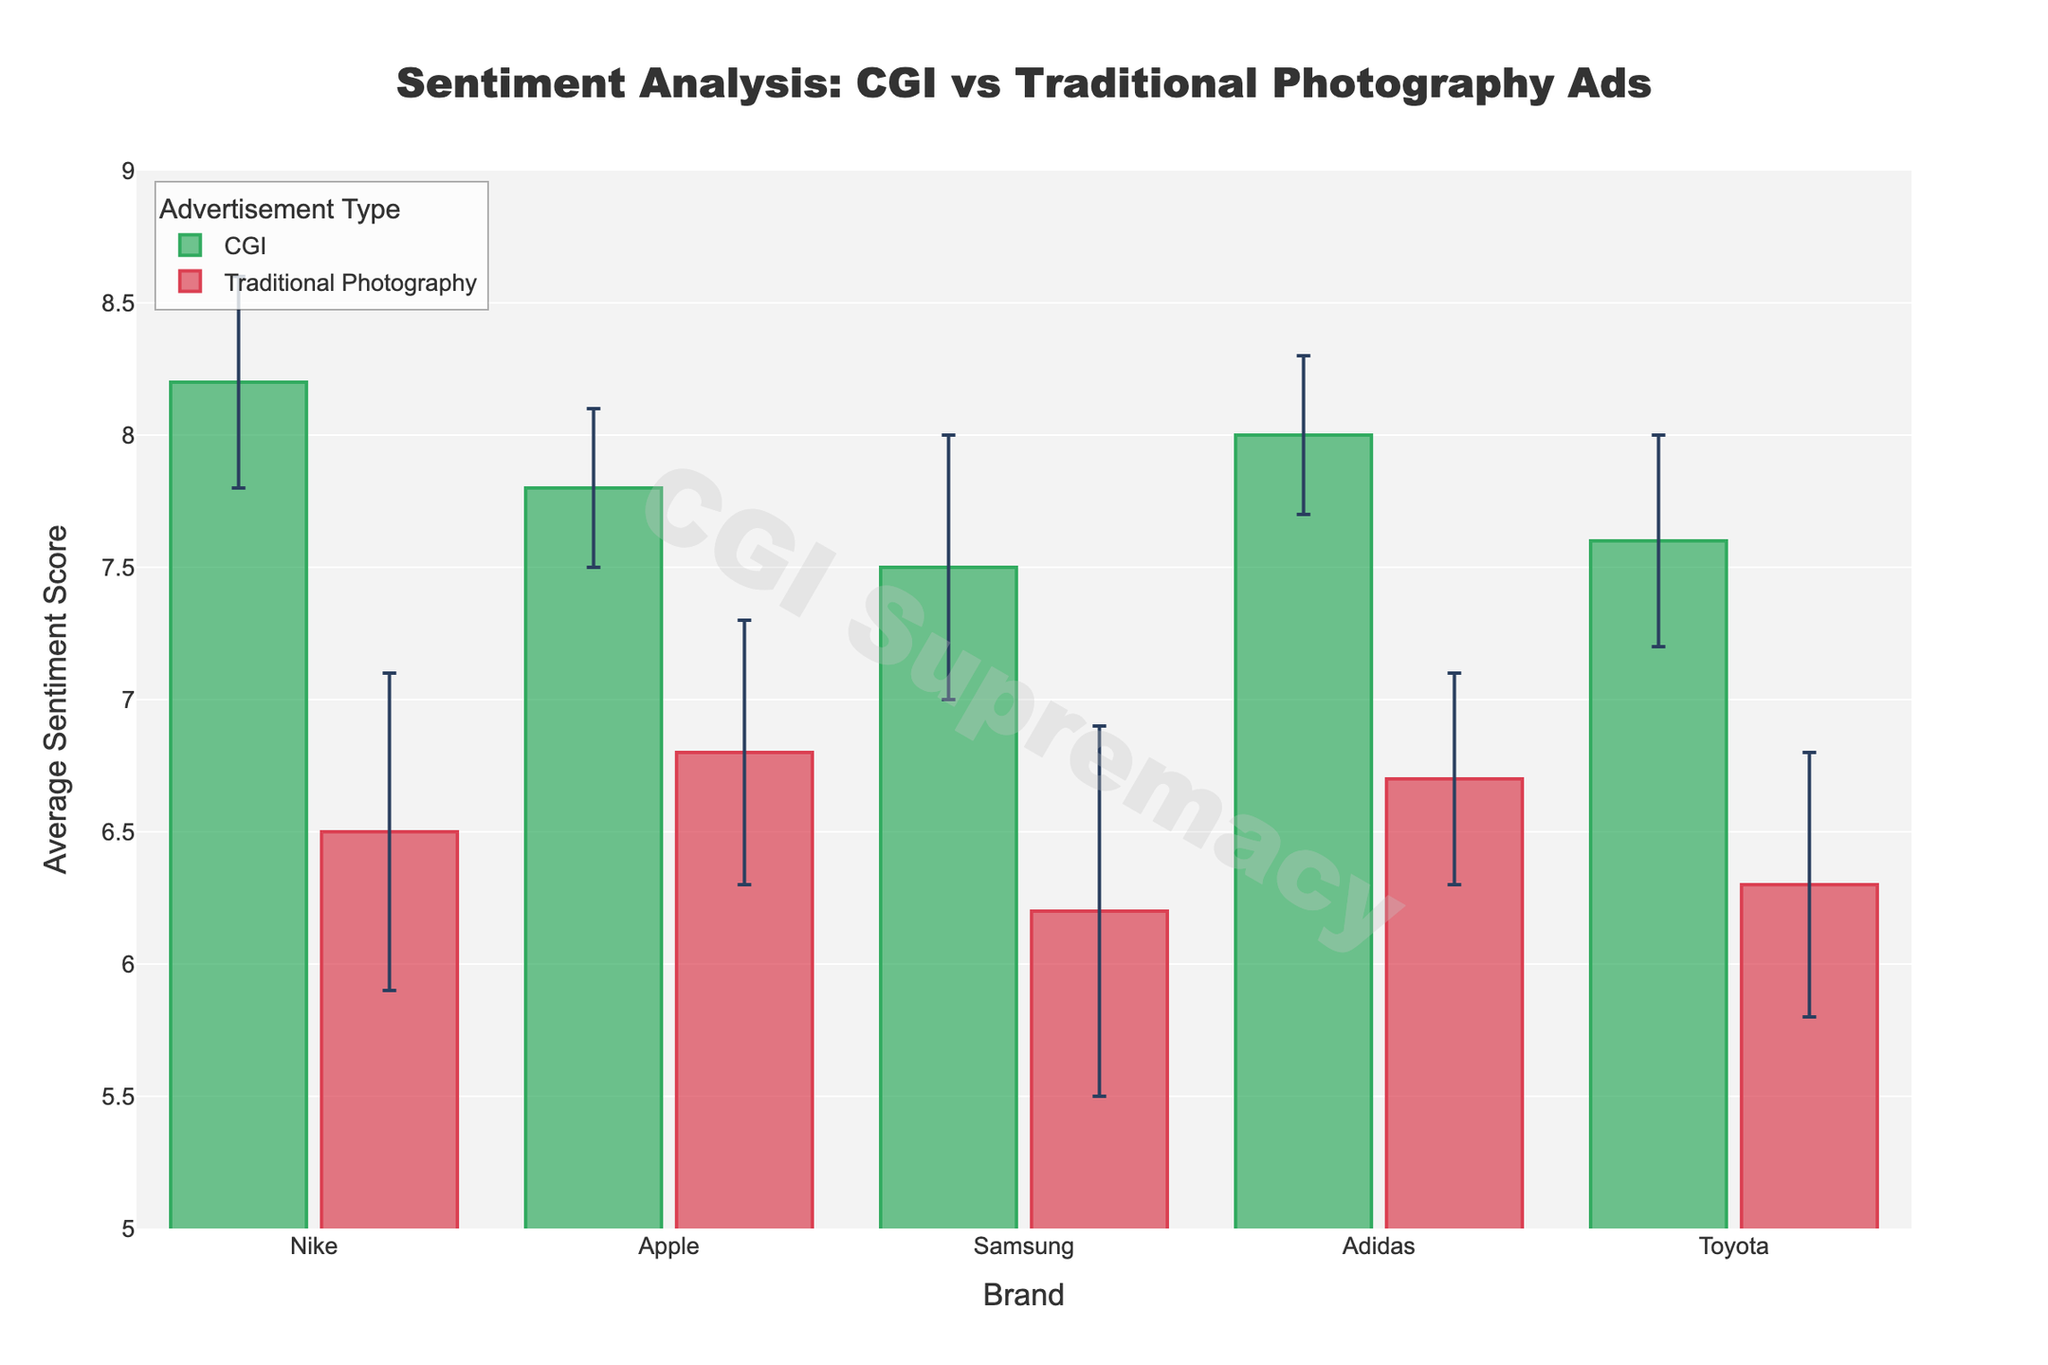What's the title of the figure? The title is prominently displayed at the top of the figure. It reads: "Sentiment Analysis: CGI vs Traditional Photography Ads".
Answer: Sentiment Analysis: CGI vs Traditional Photography Ads What is the average sentiment score of Nike's CGI advertisement? Locate the bar corresponding to Nike under the CGI category. The height of the bar, along with the y-axis, shows the average sentiment score as 8.2.
Answer: 8.2 Which brand has the highest average sentiment score for traditional photography-based ads? Compare the heights of bars under the Traditional Photography category. Apple, with a score of 6.8, stands the tallest.
Answer: Apple What is the difference in the average sentiment score between CGI and traditional ads for Adidas? Locate the bars for CGI and Traditional Photography for Adidas. CGI is 8.0, and Traditional Photography is 6.7. The difference is 8.0 - 6.7 = 1.3.
Answer: 1.3 What are the two brands with the smallest difference in average sentiment scores between CGI and traditional photography ads? Calculate the difference for each brand: 
- Nike: 8.2 - 6.5 = 1.7
- Apple: 7.8 - 6.8 = 1.0 
- Samsung: 7.5 - 6.2 = 1.3
- Adidas: 8.0 - 6.7 = 1.3 
- Toyota: 7.6 - 6.3 = 1.3 
The two smallest differences are for Apple (1.0) and Samsung, Adidas, and Toyota all having 1.3.
Answer: Apple, Samsung or Adidas or Toyota How does the standard error compare for CGI and traditional photography ads for Samsung? Look at the error bars for Samsung in both categories. CGI has an error bar of 0.5, while Traditional Photography shows 0.7. The traditional photography ad has a larger standard error.
Answer: Traditional Photography has a larger standard error Do CGI ads generally have better sentiment scores than traditional photography ads? Observe the bars' heights for each brand and see which category has higher overall scores. CGI bars are consistently taller, indicating better sentiment scores.
Answer: Yes Which advertisement type has the smallest standard error across all brands? Review the error bars for both categories across all brands. Apple’s CGI ad has the smallest error bar of 0.3.
Answer: CGI (Apple) Is there any brand where traditional photography ad has a higher sentiment score than CGI ad? Compare each pair of bars. In all cases, CGI sentiment scores are higher than Traditional Photography.
Answer: No What is the overall visual impression of sentiment scores for CGI vs traditional photography ads? CGI bars are uniformly taller and the colors (green for CGI, red for traditional) visually show CGI ads receive higher sentiment scores.
Answer: CGI ads have higher sentiment scores 